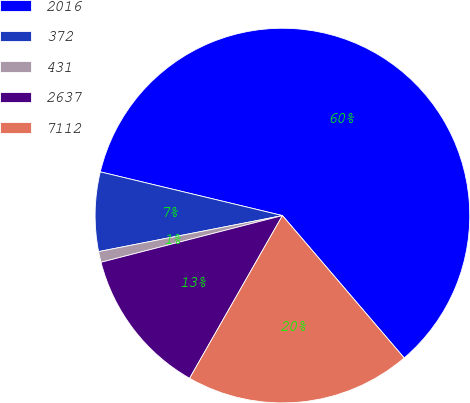Convert chart to OTSL. <chart><loc_0><loc_0><loc_500><loc_500><pie_chart><fcel>2016<fcel>372<fcel>431<fcel>2637<fcel>7112<nl><fcel>59.99%<fcel>6.83%<fcel>0.93%<fcel>12.74%<fcel>19.51%<nl></chart> 